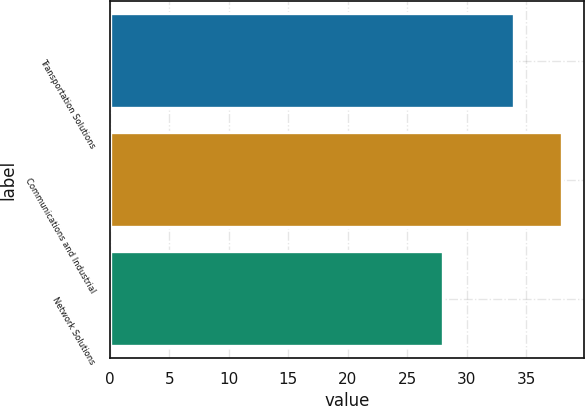<chart> <loc_0><loc_0><loc_500><loc_500><bar_chart><fcel>Transportation Solutions<fcel>Communications and Industrial<fcel>Network Solutions<nl><fcel>34<fcel>38<fcel>28<nl></chart> 